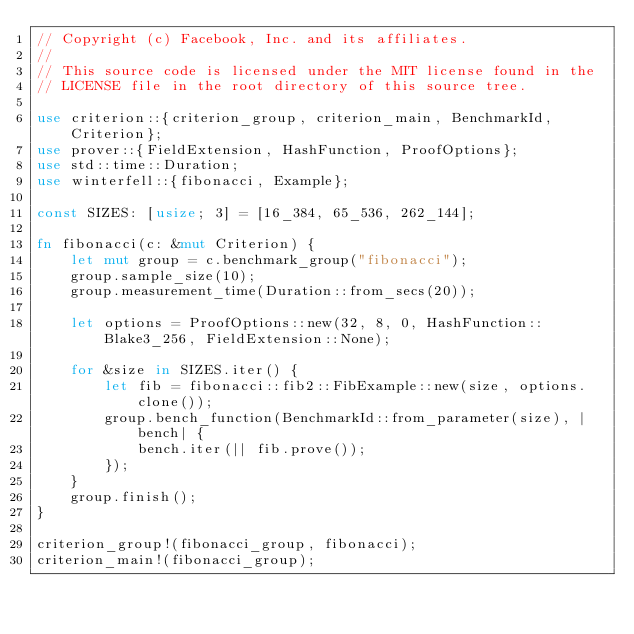<code> <loc_0><loc_0><loc_500><loc_500><_Rust_>// Copyright (c) Facebook, Inc. and its affiliates.
//
// This source code is licensed under the MIT license found in the
// LICENSE file in the root directory of this source tree.

use criterion::{criterion_group, criterion_main, BenchmarkId, Criterion};
use prover::{FieldExtension, HashFunction, ProofOptions};
use std::time::Duration;
use winterfell::{fibonacci, Example};

const SIZES: [usize; 3] = [16_384, 65_536, 262_144];

fn fibonacci(c: &mut Criterion) {
    let mut group = c.benchmark_group("fibonacci");
    group.sample_size(10);
    group.measurement_time(Duration::from_secs(20));

    let options = ProofOptions::new(32, 8, 0, HashFunction::Blake3_256, FieldExtension::None);

    for &size in SIZES.iter() {
        let fib = fibonacci::fib2::FibExample::new(size, options.clone());
        group.bench_function(BenchmarkId::from_parameter(size), |bench| {
            bench.iter(|| fib.prove());
        });
    }
    group.finish();
}

criterion_group!(fibonacci_group, fibonacci);
criterion_main!(fibonacci_group);
</code> 